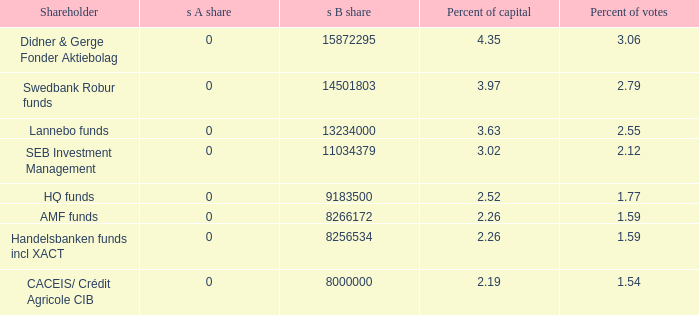What is the s B share for the shareholder that has 2.12 percent of votes?  11034379.0. 